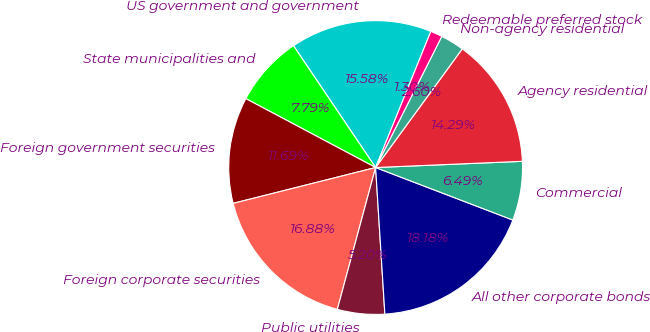Convert chart to OTSL. <chart><loc_0><loc_0><loc_500><loc_500><pie_chart><fcel>US government and government<fcel>State municipalities and<fcel>Foreign government securities<fcel>Foreign corporate securities<fcel>Public utilities<fcel>All other corporate bonds<fcel>Commercial<fcel>Agency residential<fcel>Non-agency residential<fcel>Redeemable preferred stock<nl><fcel>15.58%<fcel>7.79%<fcel>11.69%<fcel>16.88%<fcel>5.2%<fcel>18.18%<fcel>6.49%<fcel>14.29%<fcel>2.6%<fcel>1.3%<nl></chart> 